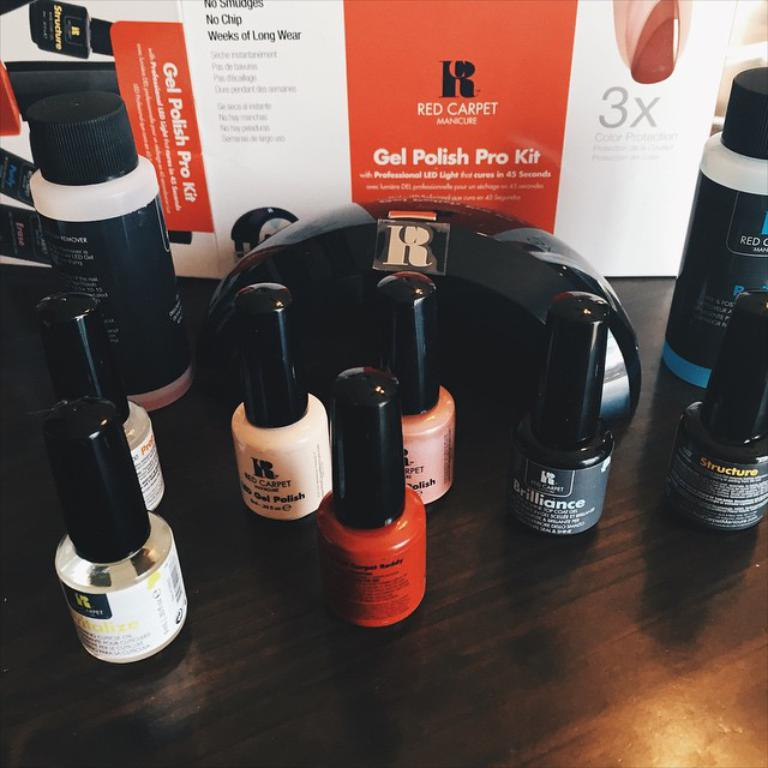<image>
Describe the image concisely. A collection of nail polish from Gel Polish Pro Kit. 